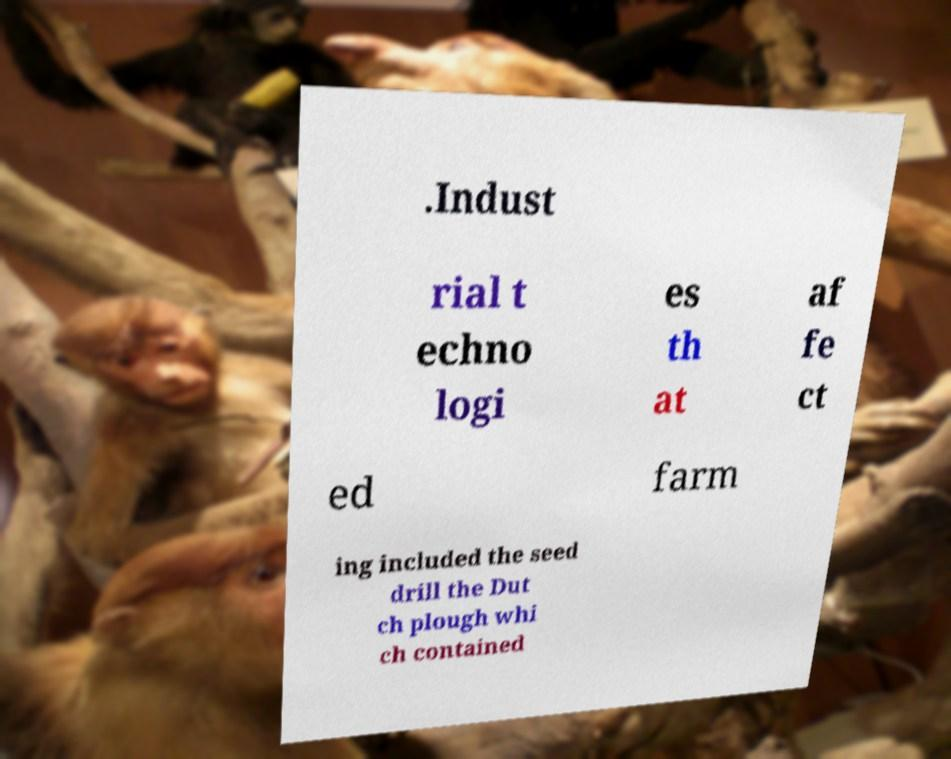What messages or text are displayed in this image? I need them in a readable, typed format. .Indust rial t echno logi es th at af fe ct ed farm ing included the seed drill the Dut ch plough whi ch contained 